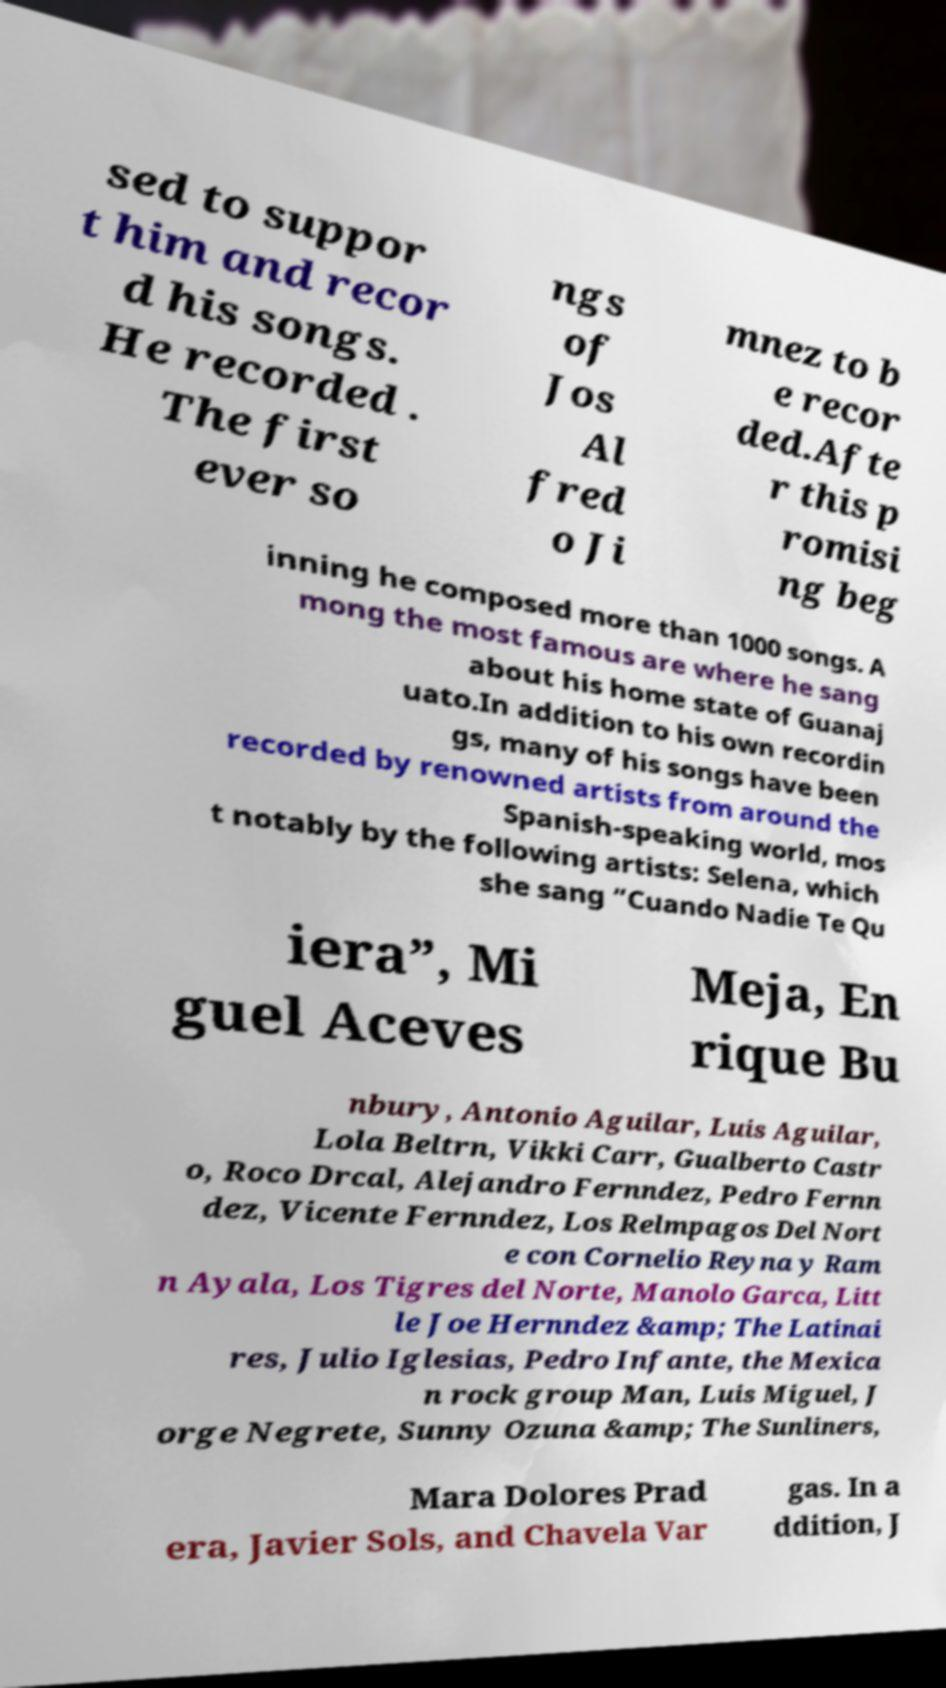I need the written content from this picture converted into text. Can you do that? sed to suppor t him and recor d his songs. He recorded . The first ever so ngs of Jos Al fred o Ji mnez to b e recor ded.Afte r this p romisi ng beg inning he composed more than 1000 songs. A mong the most famous are where he sang about his home state of Guanaj uato.In addition to his own recordin gs, many of his songs have been recorded by renowned artists from around the Spanish-speaking world, mos t notably by the following artists: Selena, which she sang “Cuando Nadie Te Qu iera”, Mi guel Aceves Meja, En rique Bu nbury, Antonio Aguilar, Luis Aguilar, Lola Beltrn, Vikki Carr, Gualberto Castr o, Roco Drcal, Alejandro Fernndez, Pedro Fernn dez, Vicente Fernndez, Los Relmpagos Del Nort e con Cornelio Reyna y Ram n Ayala, Los Tigres del Norte, Manolo Garca, Litt le Joe Hernndez &amp; The Latinai res, Julio Iglesias, Pedro Infante, the Mexica n rock group Man, Luis Miguel, J orge Negrete, Sunny Ozuna &amp; The Sunliners, Mara Dolores Prad era, Javier Sols, and Chavela Var gas. In a ddition, J 